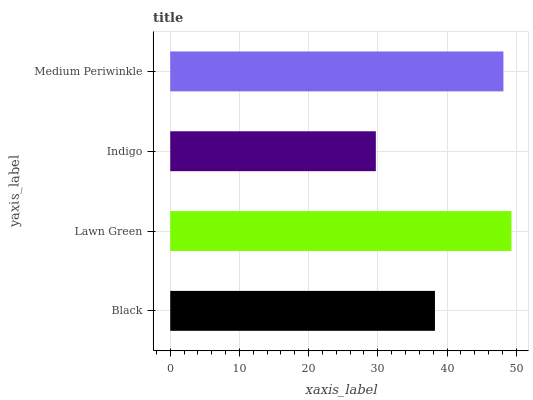Is Indigo the minimum?
Answer yes or no. Yes. Is Lawn Green the maximum?
Answer yes or no. Yes. Is Lawn Green the minimum?
Answer yes or no. No. Is Indigo the maximum?
Answer yes or no. No. Is Lawn Green greater than Indigo?
Answer yes or no. Yes. Is Indigo less than Lawn Green?
Answer yes or no. Yes. Is Indigo greater than Lawn Green?
Answer yes or no. No. Is Lawn Green less than Indigo?
Answer yes or no. No. Is Medium Periwinkle the high median?
Answer yes or no. Yes. Is Black the low median?
Answer yes or no. Yes. Is Indigo the high median?
Answer yes or no. No. Is Medium Periwinkle the low median?
Answer yes or no. No. 